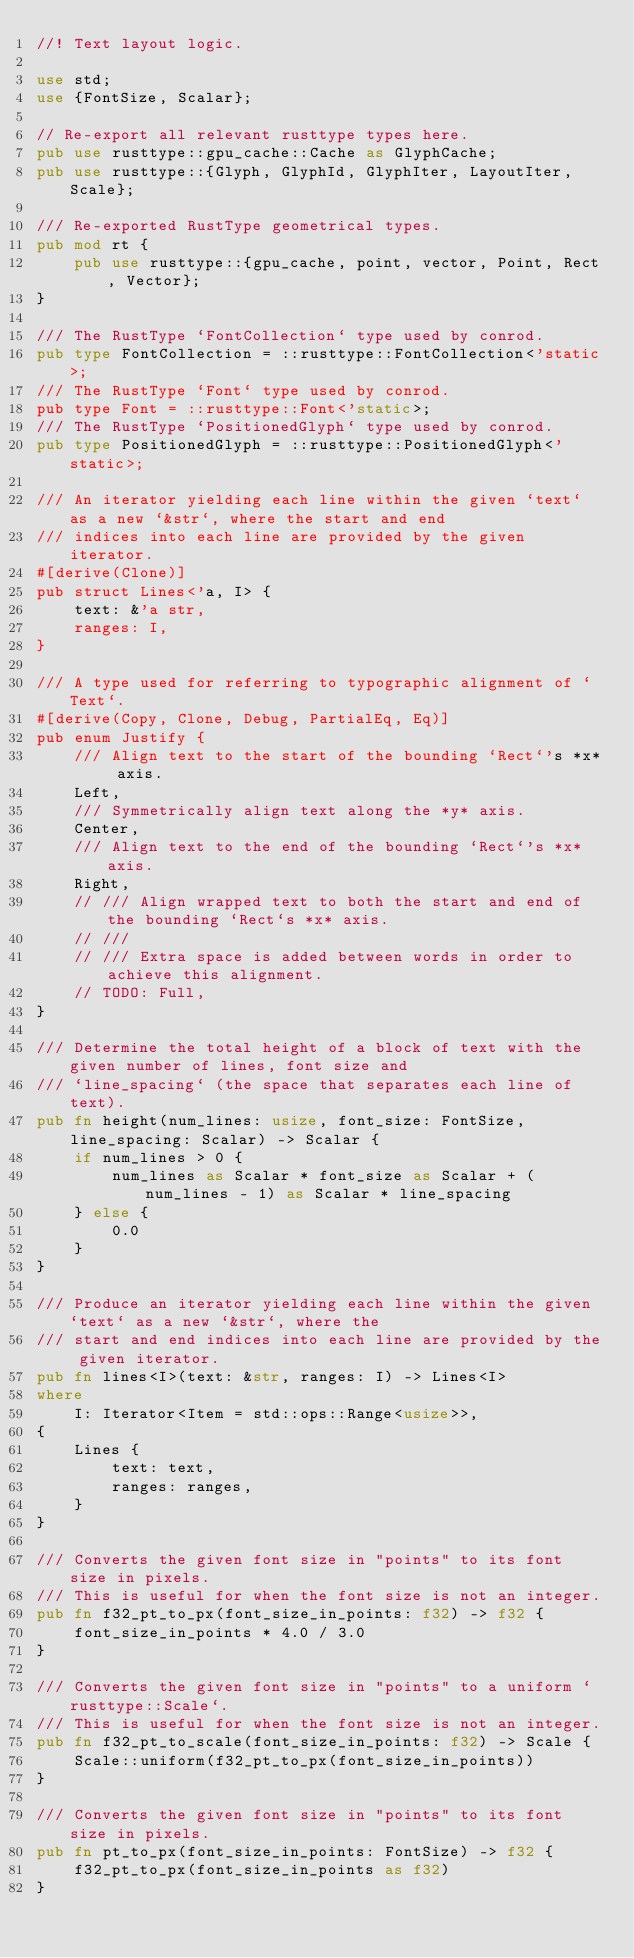Convert code to text. <code><loc_0><loc_0><loc_500><loc_500><_Rust_>//! Text layout logic.

use std;
use {FontSize, Scalar};

// Re-export all relevant rusttype types here.
pub use rusttype::gpu_cache::Cache as GlyphCache;
pub use rusttype::{Glyph, GlyphId, GlyphIter, LayoutIter, Scale};

/// Re-exported RustType geometrical types.
pub mod rt {
    pub use rusttype::{gpu_cache, point, vector, Point, Rect, Vector};
}

/// The RustType `FontCollection` type used by conrod.
pub type FontCollection = ::rusttype::FontCollection<'static>;
/// The RustType `Font` type used by conrod.
pub type Font = ::rusttype::Font<'static>;
/// The RustType `PositionedGlyph` type used by conrod.
pub type PositionedGlyph = ::rusttype::PositionedGlyph<'static>;

/// An iterator yielding each line within the given `text` as a new `&str`, where the start and end
/// indices into each line are provided by the given iterator.
#[derive(Clone)]
pub struct Lines<'a, I> {
    text: &'a str,
    ranges: I,
}

/// A type used for referring to typographic alignment of `Text`.
#[derive(Copy, Clone, Debug, PartialEq, Eq)]
pub enum Justify {
    /// Align text to the start of the bounding `Rect`'s *x* axis.
    Left,
    /// Symmetrically align text along the *y* axis.
    Center,
    /// Align text to the end of the bounding `Rect`'s *x* axis.
    Right,
    // /// Align wrapped text to both the start and end of the bounding `Rect`s *x* axis.
    // ///
    // /// Extra space is added between words in order to achieve this alignment.
    // TODO: Full,
}

/// Determine the total height of a block of text with the given number of lines, font size and
/// `line_spacing` (the space that separates each line of text).
pub fn height(num_lines: usize, font_size: FontSize, line_spacing: Scalar) -> Scalar {
    if num_lines > 0 {
        num_lines as Scalar * font_size as Scalar + (num_lines - 1) as Scalar * line_spacing
    } else {
        0.0
    }
}

/// Produce an iterator yielding each line within the given `text` as a new `&str`, where the
/// start and end indices into each line are provided by the given iterator.
pub fn lines<I>(text: &str, ranges: I) -> Lines<I>
where
    I: Iterator<Item = std::ops::Range<usize>>,
{
    Lines {
        text: text,
        ranges: ranges,
    }
}

/// Converts the given font size in "points" to its font size in pixels.
/// This is useful for when the font size is not an integer.
pub fn f32_pt_to_px(font_size_in_points: f32) -> f32 {
    font_size_in_points * 4.0 / 3.0
}

/// Converts the given font size in "points" to a uniform `rusttype::Scale`.
/// This is useful for when the font size is not an integer.
pub fn f32_pt_to_scale(font_size_in_points: f32) -> Scale {
    Scale::uniform(f32_pt_to_px(font_size_in_points))
}

/// Converts the given font size in "points" to its font size in pixels.
pub fn pt_to_px(font_size_in_points: FontSize) -> f32 {
    f32_pt_to_px(font_size_in_points as f32)
}
</code> 